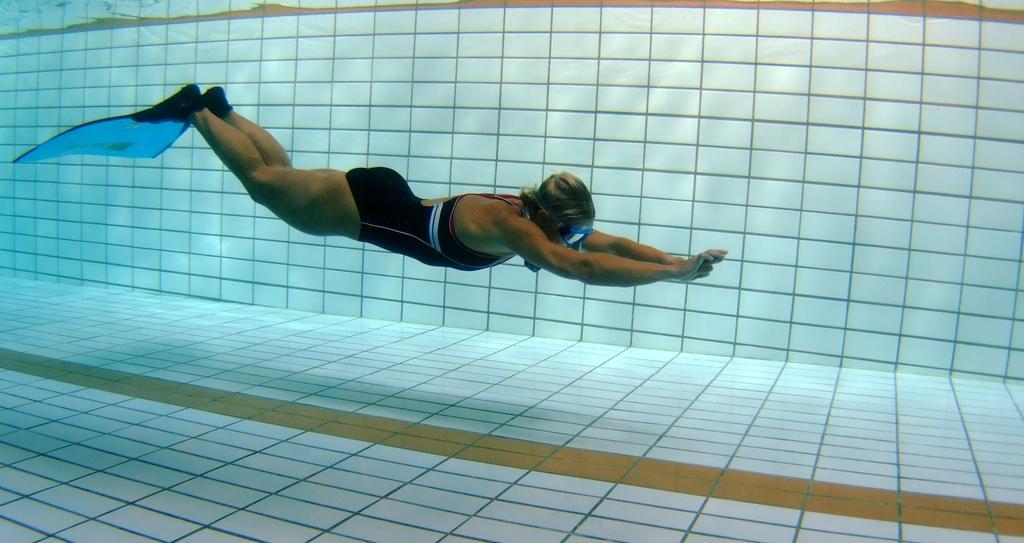Please provide a concise description of this image. In this picture I can observe a woman swimming in the water. In the background I can observe a wall. 